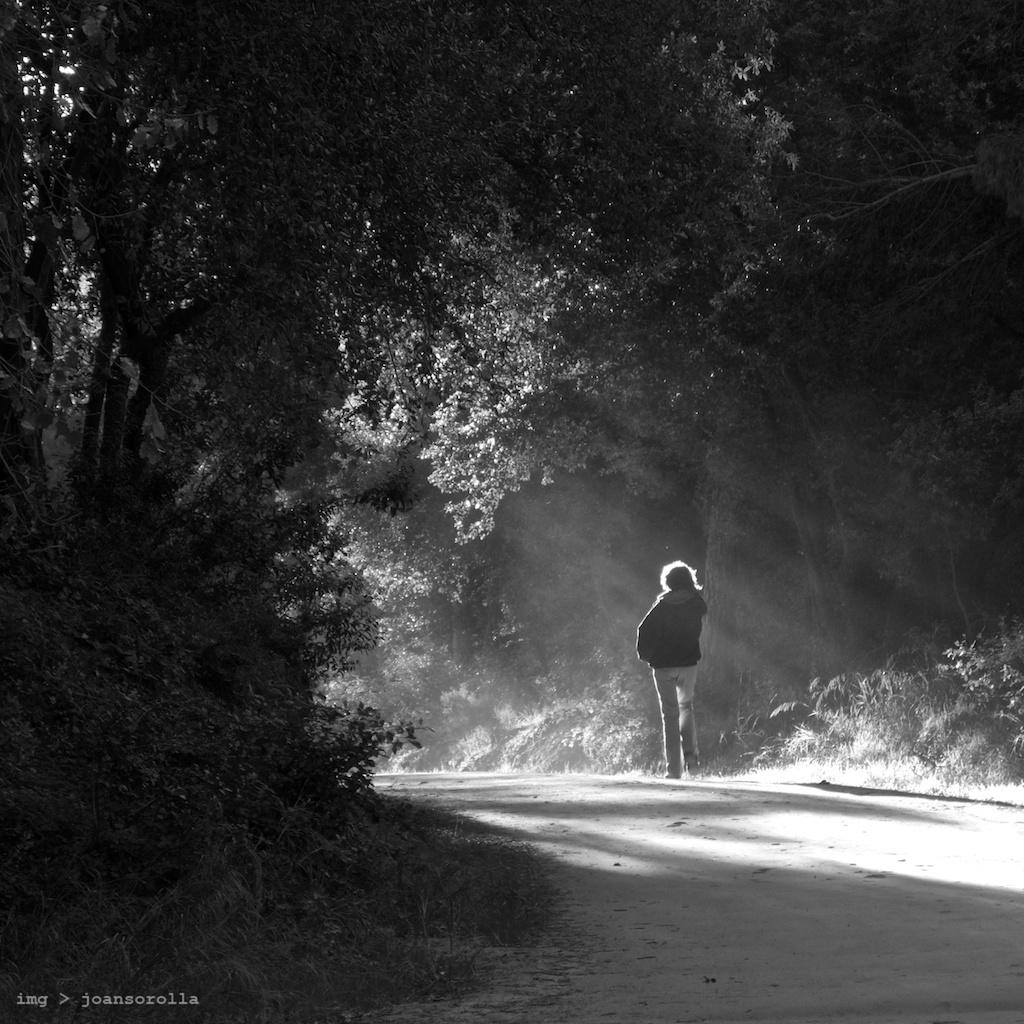What is the color scheme of the image? The image is black and white. What can be seen in the foreground of the image? There is a person standing on the road. What is visible in the background of the image? There are trees in the background. Can you describe any additional features of the image? There is a watermark in the left bottom of the image. What type of bag is the person carrying in the image? There is no bag visible in the image; the person is not carrying anything. What is the person's interest in the trees in the background? The image does not provide any information about the person's interests or intentions, so we cannot determine their interest in the trees. 